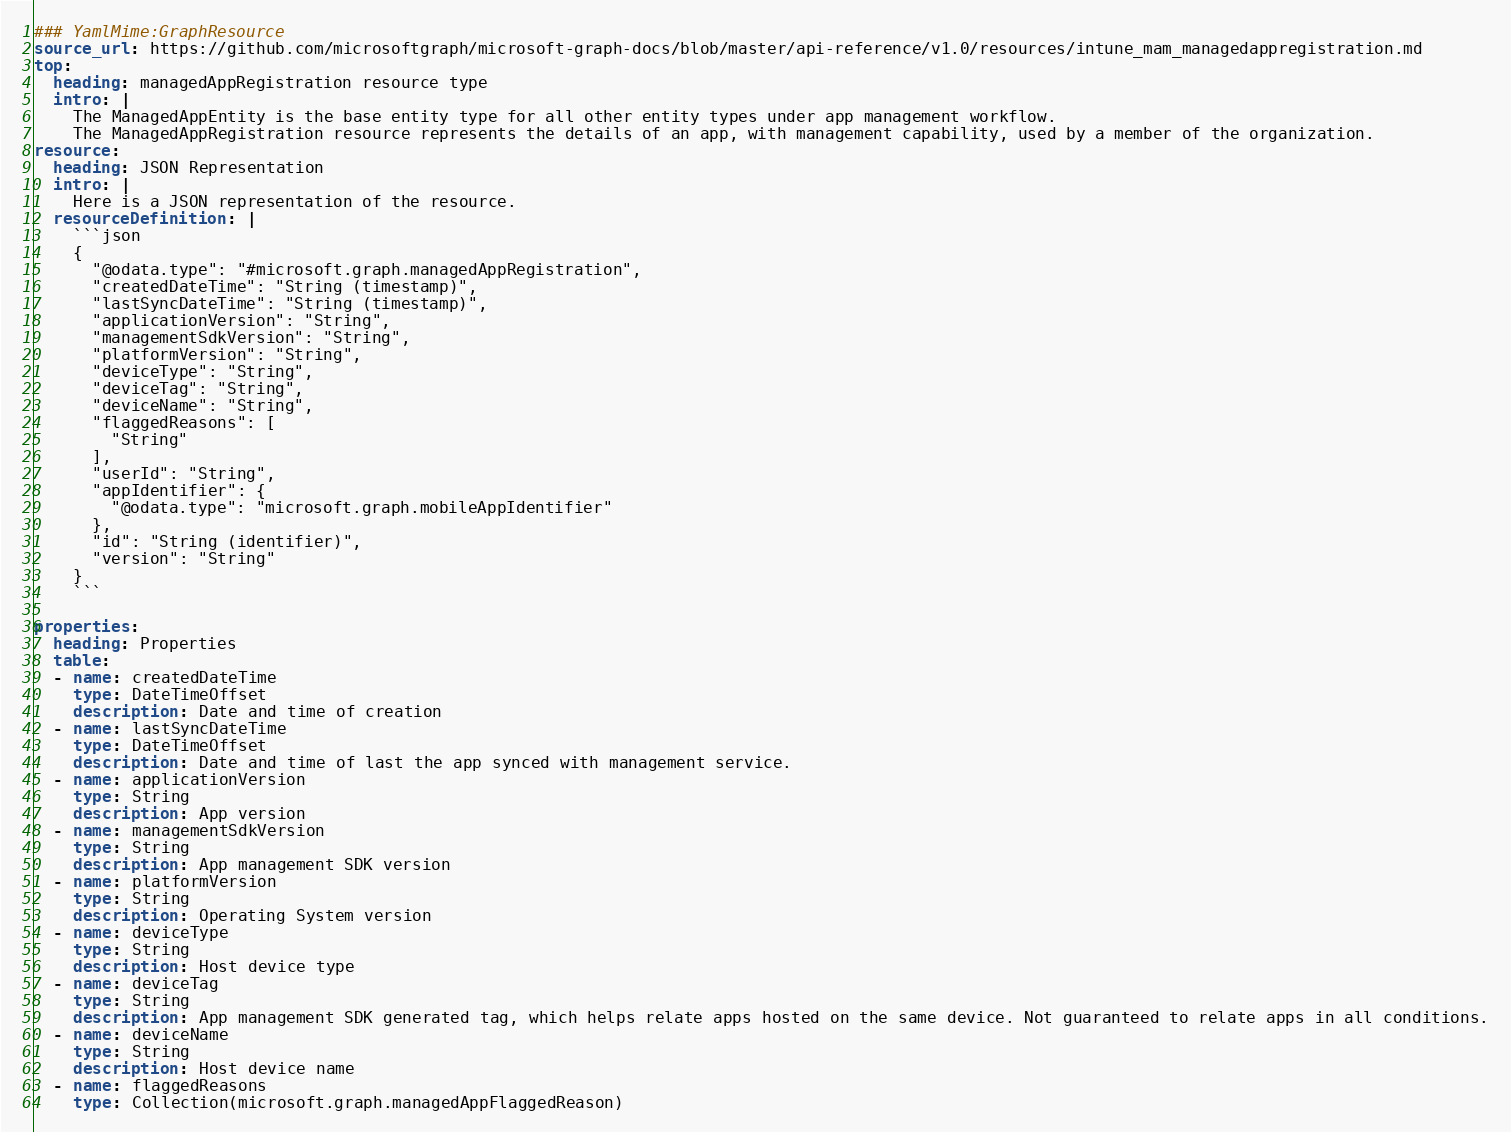Convert code to text. <code><loc_0><loc_0><loc_500><loc_500><_YAML_>### YamlMime:GraphResource
source_url: https://github.com/microsoftgraph/microsoft-graph-docs/blob/master/api-reference/v1.0/resources/intune_mam_managedappregistration.md
top:
  heading: managedAppRegistration resource type
  intro: |
    The ManagedAppEntity is the base entity type for all other entity types under app management workflow.
    The ManagedAppRegistration resource represents the details of an app, with management capability, used by a member of the organization.
resource:
  heading: JSON Representation
  intro: |
    Here is a JSON representation of the resource.
  resourceDefinition: |
    ```json
    {
      "@odata.type": "#microsoft.graph.managedAppRegistration",
      "createdDateTime": "String (timestamp)",
      "lastSyncDateTime": "String (timestamp)",
      "applicationVersion": "String",
      "managementSdkVersion": "String",
      "platformVersion": "String",
      "deviceType": "String",
      "deviceTag": "String",
      "deviceName": "String",
      "flaggedReasons": [
        "String"
      ],
      "userId": "String",
      "appIdentifier": {
        "@odata.type": "microsoft.graph.mobileAppIdentifier"
      },
      "id": "String (identifier)",
      "version": "String"
    }
    ```
    
properties:
  heading: Properties
  table:
  - name: createdDateTime
    type: DateTimeOffset
    description: Date and time of creation
  - name: lastSyncDateTime
    type: DateTimeOffset
    description: Date and time of last the app synced with management service.
  - name: applicationVersion
    type: String
    description: App version
  - name: managementSdkVersion
    type: String
    description: App management SDK version
  - name: platformVersion
    type: String
    description: Operating System version
  - name: deviceType
    type: String
    description: Host device type
  - name: deviceTag
    type: String
    description: App management SDK generated tag, which helps relate apps hosted on the same device. Not guaranteed to relate apps in all conditions.
  - name: deviceName
    type: String
    description: Host device name
  - name: flaggedReasons
    type: Collection(microsoft.graph.managedAppFlaggedReason)</code> 